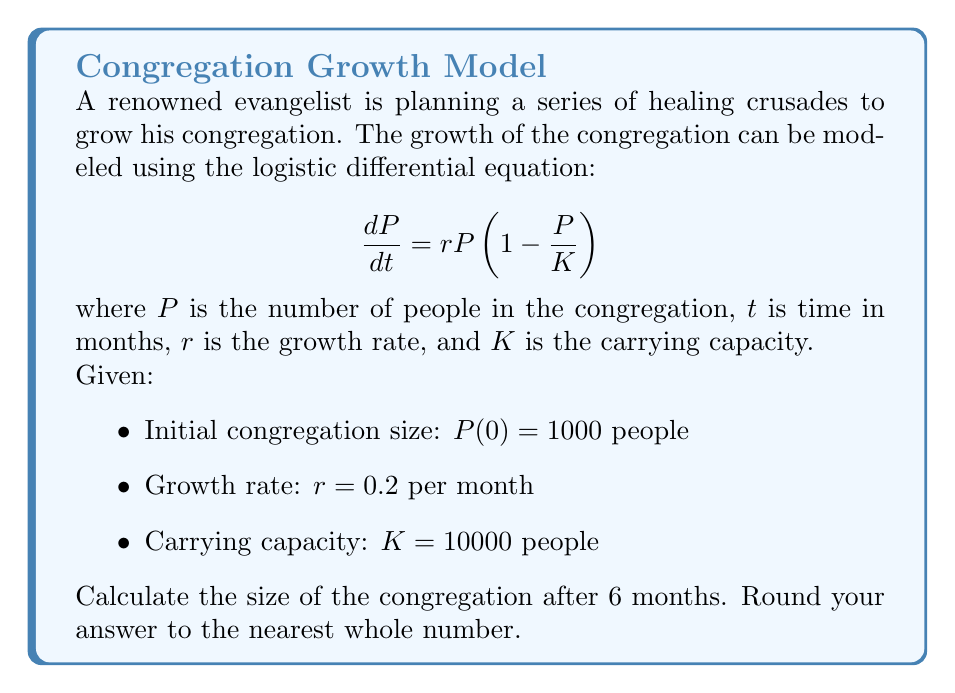Provide a solution to this math problem. To solve this problem, we need to use the solution to the logistic differential equation:

$$P(t) = \frac{K}{1 + (\frac{K}{P_0} - 1)e^{-rt}}$$

Where:
$P(t)$ is the population at time $t$
$K$ is the carrying capacity
$P_0$ is the initial population
$r$ is the growth rate
$t$ is the time

Let's plug in our values:

$K = 10000$
$P_0 = 1000$
$r = 0.2$
$t = 6$

$$P(6) = \frac{10000}{1 + (\frac{10000}{1000} - 1)e^{-0.2 \cdot 6}}$$

Simplifying:

$$P(6) = \frac{10000}{1 + 9e^{-1.2}}$$

Now, let's calculate:

$e^{-1.2} \approx 0.3012$

$$P(6) = \frac{10000}{1 + 9 \cdot 0.3012} \approx 3723.84$$

Rounding to the nearest whole number:

$P(6) \approx 3724$ people
Answer: 3724 people 